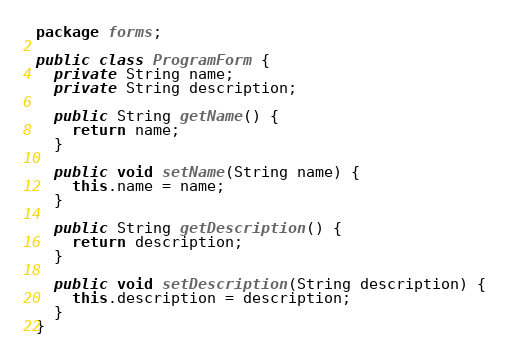Convert code to text. <code><loc_0><loc_0><loc_500><loc_500><_Java_>package forms;

public class ProgramForm {
  private String name;
  private String description;

  public String getName() {
    return name;
  }

  public void setName(String name) {
    this.name = name;
  }

  public String getDescription() {
    return description;
  }

  public void setDescription(String description) {
    this.description = description;
  }
}
</code> 